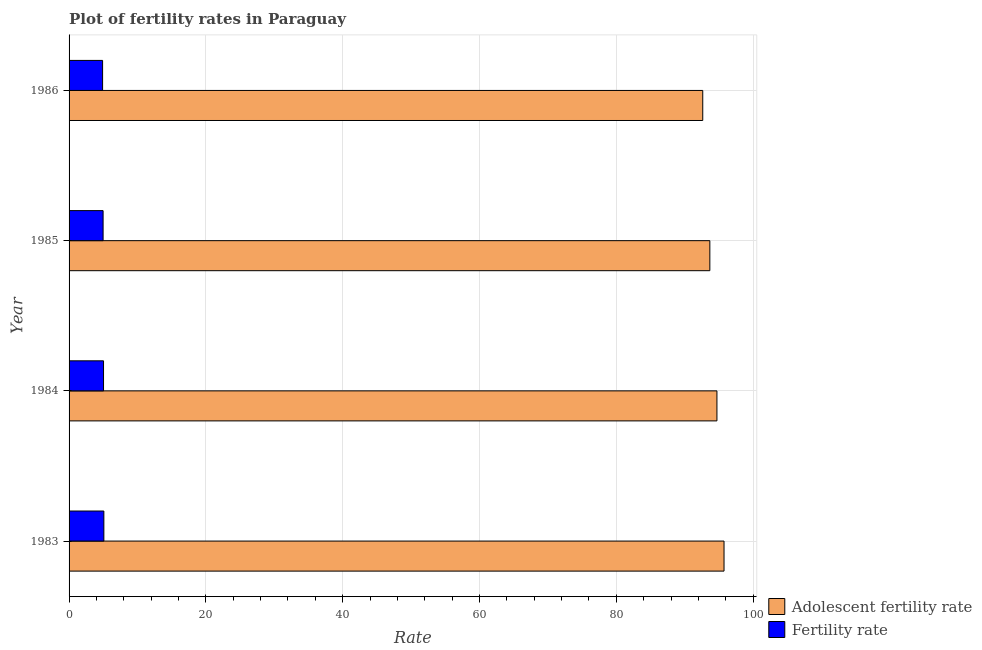How many different coloured bars are there?
Provide a succinct answer. 2. How many groups of bars are there?
Provide a succinct answer. 4. Are the number of bars on each tick of the Y-axis equal?
Offer a very short reply. Yes. What is the label of the 4th group of bars from the top?
Your response must be concise. 1983. What is the fertility rate in 1984?
Ensure brevity in your answer.  5.04. Across all years, what is the maximum fertility rate?
Make the answer very short. 5.09. Across all years, what is the minimum adolescent fertility rate?
Provide a short and direct response. 92.64. In which year was the adolescent fertility rate minimum?
Offer a very short reply. 1986. What is the total fertility rate in the graph?
Provide a succinct answer. 20. What is the difference between the fertility rate in 1984 and that in 1986?
Your answer should be very brief. 0.14. What is the difference between the adolescent fertility rate in 1985 and the fertility rate in 1984?
Ensure brevity in your answer.  88.64. What is the average fertility rate per year?
Your response must be concise. 5. In the year 1984, what is the difference between the adolescent fertility rate and fertility rate?
Offer a very short reply. 89.68. In how many years, is the adolescent fertility rate greater than 32 ?
Your answer should be very brief. 4. What is the ratio of the adolescent fertility rate in 1985 to that in 1986?
Make the answer very short. 1.01. Is the fertility rate in 1983 less than that in 1984?
Give a very brief answer. No. Is the difference between the adolescent fertility rate in 1984 and 1986 greater than the difference between the fertility rate in 1984 and 1986?
Provide a succinct answer. Yes. What is the difference between the highest and the lowest fertility rate?
Give a very brief answer. 0.19. In how many years, is the adolescent fertility rate greater than the average adolescent fertility rate taken over all years?
Make the answer very short. 2. What does the 2nd bar from the top in 1983 represents?
Keep it short and to the point. Adolescent fertility rate. What does the 2nd bar from the bottom in 1985 represents?
Provide a succinct answer. Fertility rate. Are all the bars in the graph horizontal?
Ensure brevity in your answer.  Yes. How many legend labels are there?
Give a very brief answer. 2. How are the legend labels stacked?
Make the answer very short. Vertical. What is the title of the graph?
Your answer should be very brief. Plot of fertility rates in Paraguay. What is the label or title of the X-axis?
Keep it short and to the point. Rate. What is the Rate of Adolescent fertility rate in 1983?
Provide a succinct answer. 95.75. What is the Rate in Fertility rate in 1983?
Give a very brief answer. 5.09. What is the Rate of Adolescent fertility rate in 1984?
Offer a very short reply. 94.71. What is the Rate of Fertility rate in 1984?
Your answer should be compact. 5.04. What is the Rate in Adolescent fertility rate in 1985?
Keep it short and to the point. 93.68. What is the Rate in Fertility rate in 1985?
Your answer should be compact. 4.97. What is the Rate of Adolescent fertility rate in 1986?
Give a very brief answer. 92.64. Across all years, what is the maximum Rate of Adolescent fertility rate?
Make the answer very short. 95.75. Across all years, what is the maximum Rate of Fertility rate?
Your response must be concise. 5.09. Across all years, what is the minimum Rate in Adolescent fertility rate?
Ensure brevity in your answer.  92.64. What is the total Rate of Adolescent fertility rate in the graph?
Your answer should be very brief. 376.78. What is the total Rate in Fertility rate in the graph?
Make the answer very short. 20. What is the difference between the Rate in Adolescent fertility rate in 1983 and that in 1984?
Make the answer very short. 1.04. What is the difference between the Rate of Fertility rate in 1983 and that in 1984?
Give a very brief answer. 0.05. What is the difference between the Rate of Adolescent fertility rate in 1983 and that in 1985?
Offer a very short reply. 2.07. What is the difference between the Rate of Fertility rate in 1983 and that in 1985?
Your answer should be compact. 0.11. What is the difference between the Rate in Adolescent fertility rate in 1983 and that in 1986?
Keep it short and to the point. 3.11. What is the difference between the Rate of Fertility rate in 1983 and that in 1986?
Keep it short and to the point. 0.19. What is the difference between the Rate in Fertility rate in 1984 and that in 1985?
Provide a succinct answer. 0.06. What is the difference between the Rate in Adolescent fertility rate in 1984 and that in 1986?
Your answer should be compact. 2.07. What is the difference between the Rate in Fertility rate in 1984 and that in 1986?
Provide a succinct answer. 0.14. What is the difference between the Rate of Fertility rate in 1985 and that in 1986?
Ensure brevity in your answer.  0.07. What is the difference between the Rate of Adolescent fertility rate in 1983 and the Rate of Fertility rate in 1984?
Provide a succinct answer. 90.71. What is the difference between the Rate in Adolescent fertility rate in 1983 and the Rate in Fertility rate in 1985?
Give a very brief answer. 90.78. What is the difference between the Rate of Adolescent fertility rate in 1983 and the Rate of Fertility rate in 1986?
Make the answer very short. 90.85. What is the difference between the Rate of Adolescent fertility rate in 1984 and the Rate of Fertility rate in 1985?
Make the answer very short. 89.74. What is the difference between the Rate in Adolescent fertility rate in 1984 and the Rate in Fertility rate in 1986?
Provide a succinct answer. 89.81. What is the difference between the Rate in Adolescent fertility rate in 1985 and the Rate in Fertility rate in 1986?
Ensure brevity in your answer.  88.78. What is the average Rate of Adolescent fertility rate per year?
Provide a short and direct response. 94.2. What is the average Rate of Fertility rate per year?
Your response must be concise. 5. In the year 1983, what is the difference between the Rate of Adolescent fertility rate and Rate of Fertility rate?
Your answer should be very brief. 90.66. In the year 1984, what is the difference between the Rate in Adolescent fertility rate and Rate in Fertility rate?
Your answer should be compact. 89.68. In the year 1985, what is the difference between the Rate in Adolescent fertility rate and Rate in Fertility rate?
Your response must be concise. 88.7. In the year 1986, what is the difference between the Rate of Adolescent fertility rate and Rate of Fertility rate?
Offer a very short reply. 87.74. What is the ratio of the Rate in Adolescent fertility rate in 1983 to that in 1984?
Make the answer very short. 1.01. What is the ratio of the Rate in Fertility rate in 1983 to that in 1984?
Provide a short and direct response. 1.01. What is the ratio of the Rate in Adolescent fertility rate in 1983 to that in 1985?
Your response must be concise. 1.02. What is the ratio of the Rate in Fertility rate in 1983 to that in 1985?
Your answer should be very brief. 1.02. What is the ratio of the Rate in Adolescent fertility rate in 1983 to that in 1986?
Give a very brief answer. 1.03. What is the ratio of the Rate in Fertility rate in 1983 to that in 1986?
Ensure brevity in your answer.  1.04. What is the ratio of the Rate in Adolescent fertility rate in 1984 to that in 1985?
Offer a terse response. 1.01. What is the ratio of the Rate in Fertility rate in 1984 to that in 1985?
Provide a short and direct response. 1.01. What is the ratio of the Rate of Adolescent fertility rate in 1984 to that in 1986?
Keep it short and to the point. 1.02. What is the ratio of the Rate in Fertility rate in 1984 to that in 1986?
Your answer should be very brief. 1.03. What is the ratio of the Rate of Adolescent fertility rate in 1985 to that in 1986?
Provide a succinct answer. 1.01. What is the ratio of the Rate of Fertility rate in 1985 to that in 1986?
Ensure brevity in your answer.  1.02. What is the difference between the highest and the second highest Rate of Adolescent fertility rate?
Your answer should be compact. 1.04. What is the difference between the highest and the lowest Rate of Adolescent fertility rate?
Your answer should be very brief. 3.11. What is the difference between the highest and the lowest Rate in Fertility rate?
Your answer should be compact. 0.19. 